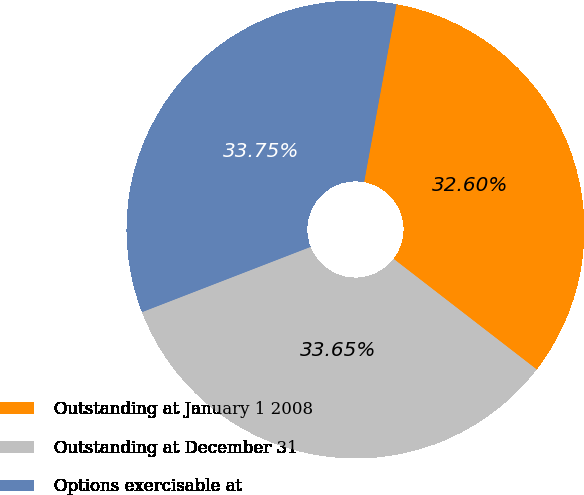Convert chart to OTSL. <chart><loc_0><loc_0><loc_500><loc_500><pie_chart><fcel>Outstanding at January 1 2008<fcel>Outstanding at December 31<fcel>Options exercisable at<nl><fcel>32.6%<fcel>33.65%<fcel>33.75%<nl></chart> 